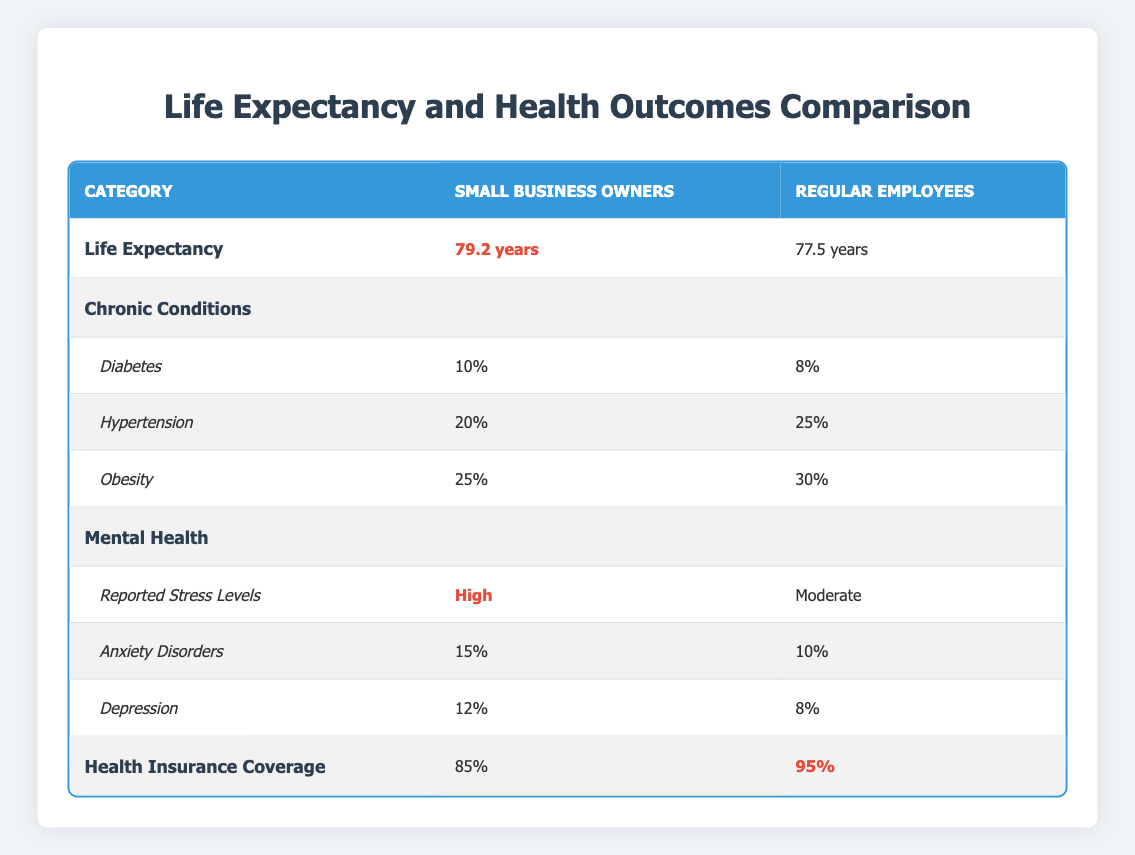What is the life expectancy of small business owners? The life expectancy for small business owners is explicitly listed in the table under the 'Life Expectancy' category. It states that their life expectancy is 79.2 years.
Answer: 79.2 years How does the life expectancy of regular employees compare to that of small business owners? The table shows that regular employees have a life expectancy of 77.5 years, which is 1.7 years less than the life expectancy of small business owners, which is 79.2 years. This can be calculated by subtracting the two values: 79.2 - 77.5 = 1.7.
Answer: 1.7 years What percentage of small business owners report suffering from obesity? The table provides the percentage of small business owners experiencing obesity under the 'Chronic Conditions' category, which states that 25% report obesity.
Answer: 25% Is the prevalence of hypertension higher among small business owners or regular employees? The table states that 20% of small business owners have hypertension while 25% of regular employees do. Therefore, regular employees have a higher prevalence of hypertension.
Answer: Regular employees What is the average percentage of reported anxiety disorders among small business owners and regular employees? To find the average percentage of reported anxiety disorders, we add the two percentages: 15% (small business owners) + 10% (regular employees) = 25%. Then, we divide by 2 to find the average: 25% / 2 = 12.5%.
Answer: 12.5% Are small business owners less covered by health insurance compared to regular employees? The table indicates that 85% of small business owners have health insurance coverage while 95% of regular employees are covered. Thus, small business owners are less covered by health insurance.
Answer: Yes How many more small business owners report high stress levels compared to regular employees? In the table, small business owners have high reported stress levels, while regular employees report moderate stress levels. The comparison does not provide a percentage for high stress among regular employees, so no numerical difference can be calculated. However, it is clear from the qualitative descriptors that small business owners report higher stress.
Answer: N/A (Qualitative comparison) What is the difference in the percentage of diabetes between small business owners and regular employees? The table shows that 10% of small business owners suffer from diabetes, while 8% of regular employees do. To find the difference, we subtract the two percentages: 10% - 8% = 2%.
Answer: 2% 